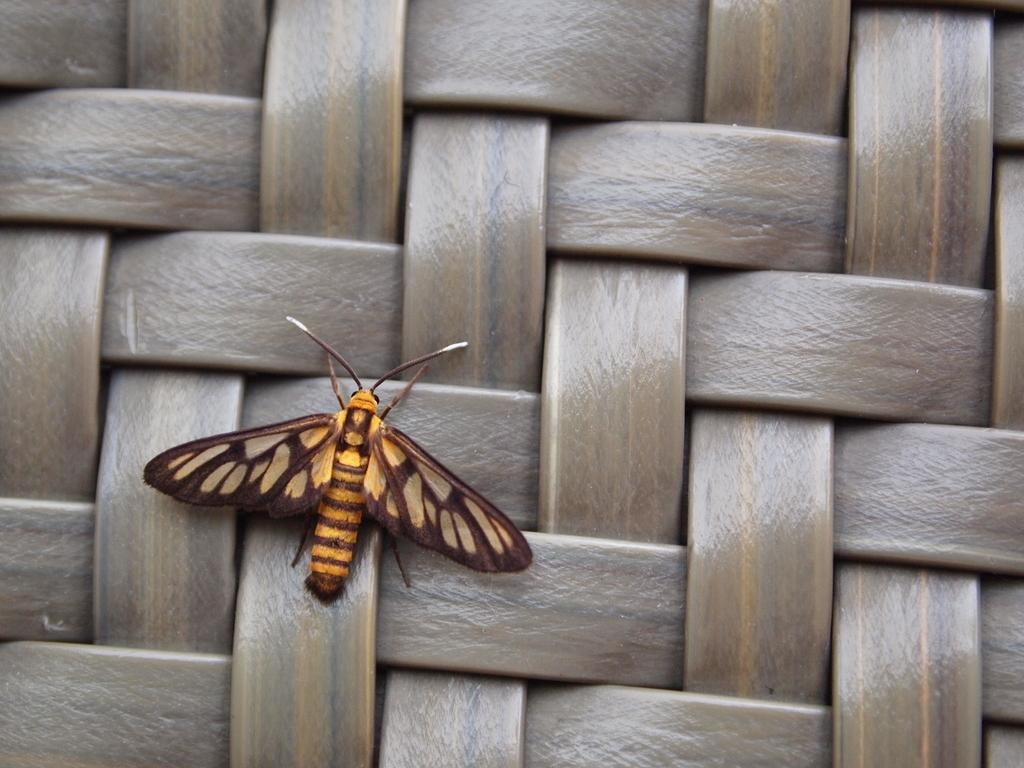What type of creature is present in the image? There is an insect in the image. Can you describe the colors of the insect? The insect has brown and yellow colors. What color is dominant in the background of the image? The background of the image has a brown color. Is there any other animal or object mentioned in the background? There might be a cat with nylon strips in the background. What type of crime is being committed in the image? There is no crime present in the image; it features an insect with brown and yellow colors against a brown background. What type of wine is being served in the image? There is no wine present in the image; it features an insect and possibly a cat with nylon strips in the background. 